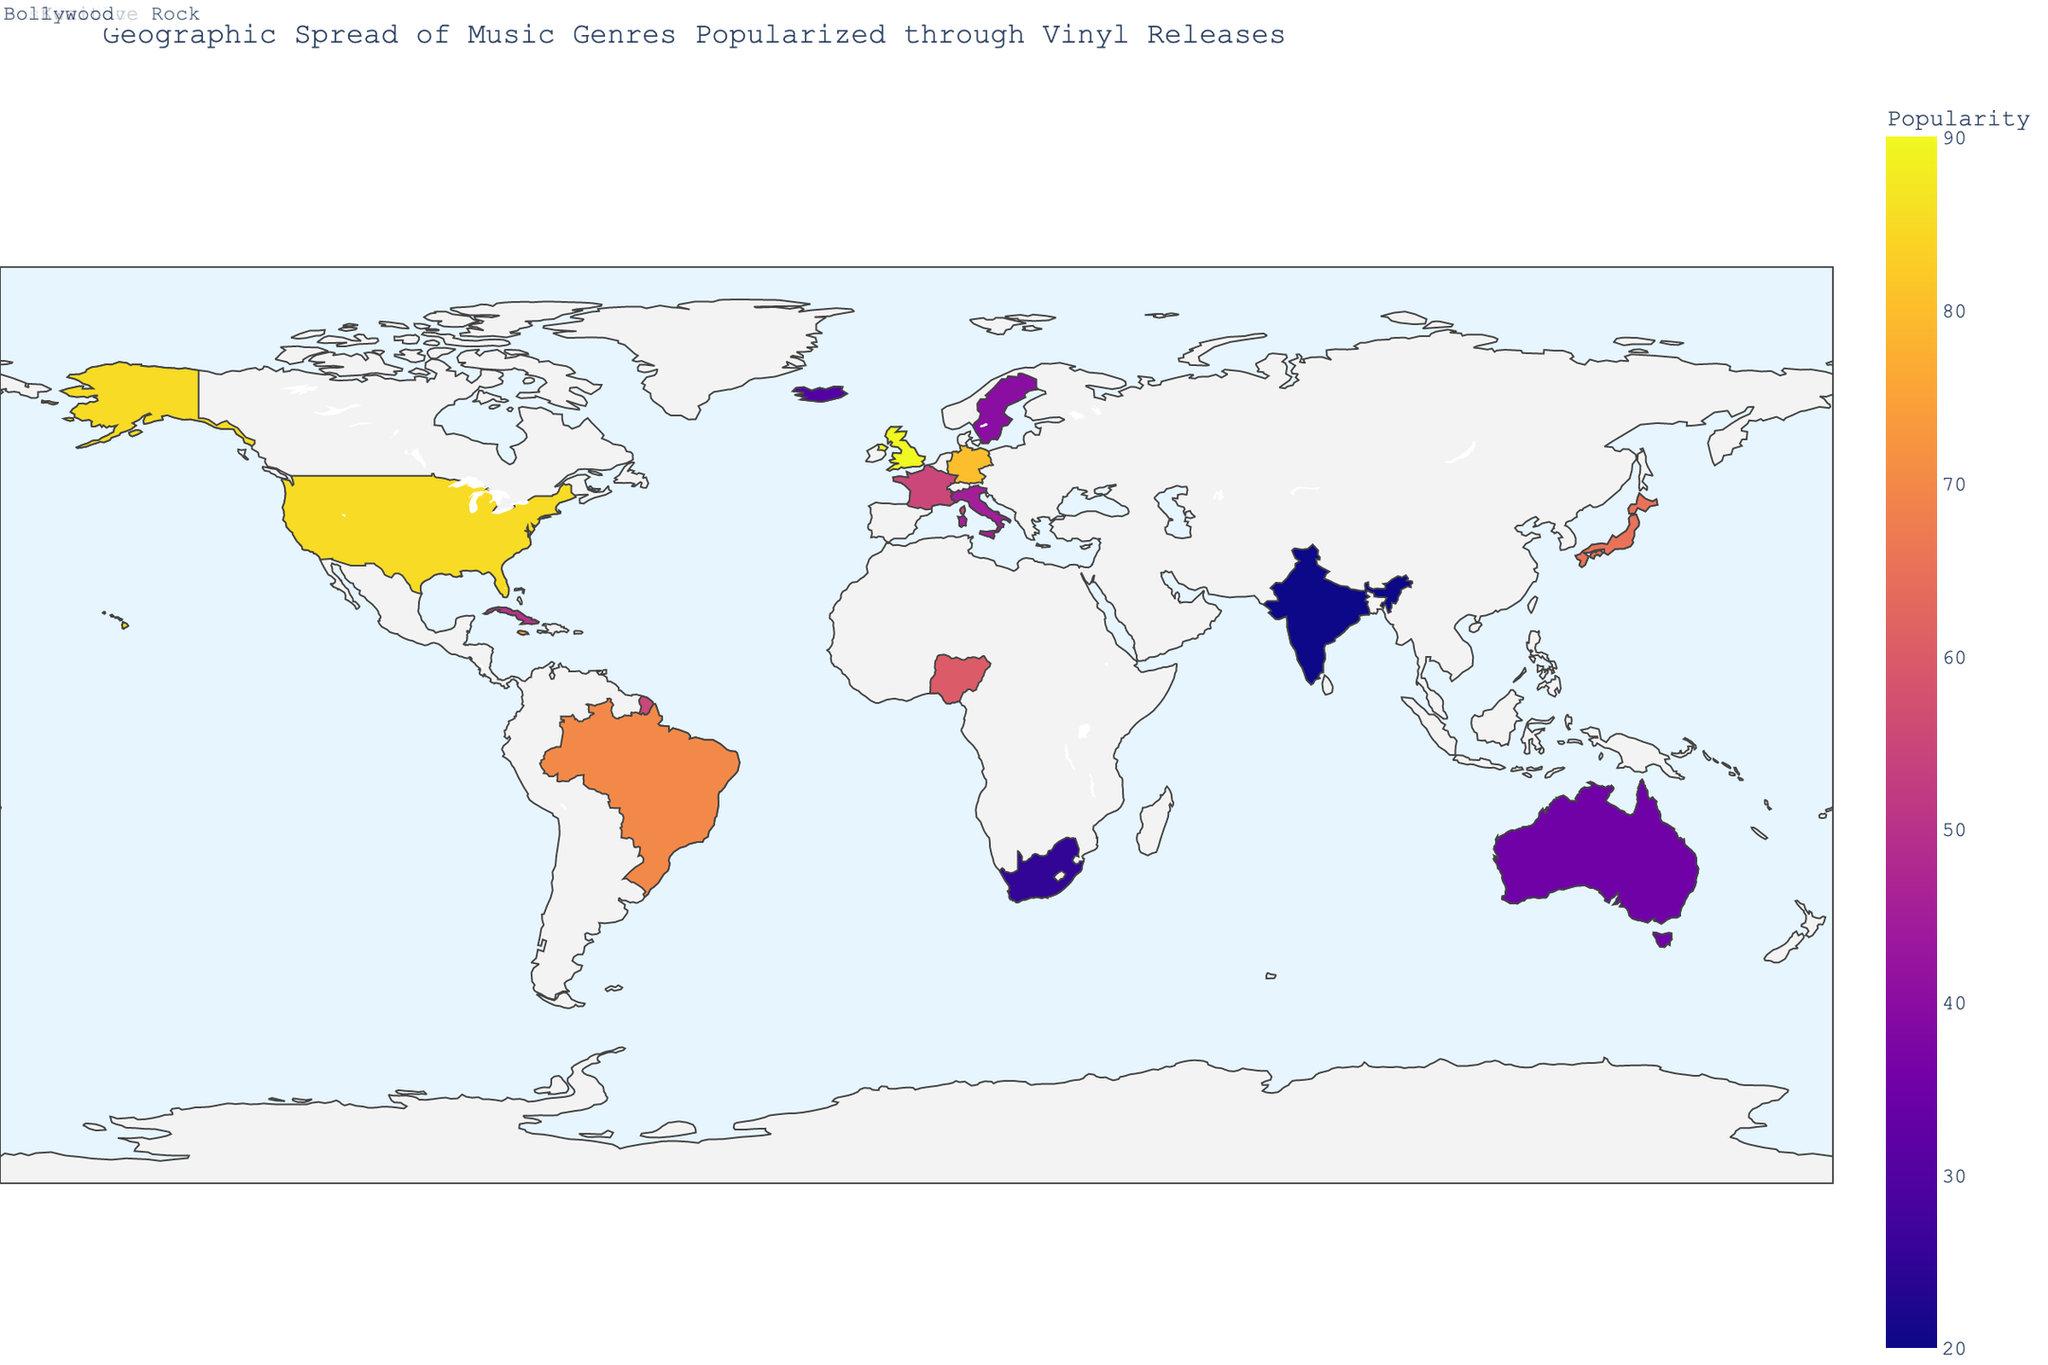How many countries are represented in the figure? Count the number of unique countries listed in the data. Each country is paired with a genre and its popularity score.
Answer: 15 Which country has the highest popularity score, and what genre does it represent? Identify the country with the maximum popularity value and note the associated genre. The United Kingdom has a score of 90 for Rock.
Answer: United Kingdom, Rock What is the average popularity score across all genres? To find the average, sum all the popularity scores (85 + 90 + 75 + 80 + 70 + 65 + 60 + 55 + 50 + 45 + 40 + 35 + 30 + 25 + 20 = 815) and divide by the number of countries (15). The calculation is 815 / 15.
Answer: 54.33 Which music genre has the lowest popularity score, and which country does it belong to? Look at the data and find the minimum popularity value. India has the lowest score of 20 for Bollywood.
Answer: Bollywood, India Compare the popularity of Jazz in the United States with Bossa Nova in Brazil. Which is more popular? The popularity score for Jazz in the United States is 85, while Bossa Nova in Brazil is 70. 85 is greater than 70.
Answer: Jazz (United States) Are there any countries with a popularity score above 80? If so, which ones and what genres do they represent? Check each country's popularity score and list those with values greater than 80 along with their genres. The countries are the United States (Jazz, 85) and the United Kingdom (Rock, 90).
Answer: United States (Jazz), United Kingdom (Rock) How does the popularity of Electronic in Germany compare to Synth-pop in Sweden? Electronic in Germany has a popularity score of 80, while Synth-pop in Sweden has a score of 40. 80 is greater than 40.
Answer: Electronic (Germany) Calculate the difference in popularity between Reggae in Jamaica and Afrobeat in Nigeria. Subtract the popularity of Afrobeat in Nigeria (60) from the popularity of Reggae in Jamaica (75). The calculation is 75 - 60.
Answer: 15 What is the combined popularity score for genres represented in countries from South America? Identify the countries in South America from the data (Brazil and Cuba), sum their popularity scores. Bossa Nova in Brazil (70) and Son Cubano in Cuba (50) have a combined score of 70 + 50.
Answer: 120 Is there a greater representation of genres with a popularity above or below 50? Count the number of genres with popularity scores above and below 50. Above 50 are 8 genres (United States, United Kingdom, Jamaica, Germany, Brazil, Japan, Nigeria, France) and below 50 are 7 genres (Cuba, Italy, Sweden, Australia, Iceland, South Africa, India). More genres are above 50.
Answer: Above 50 